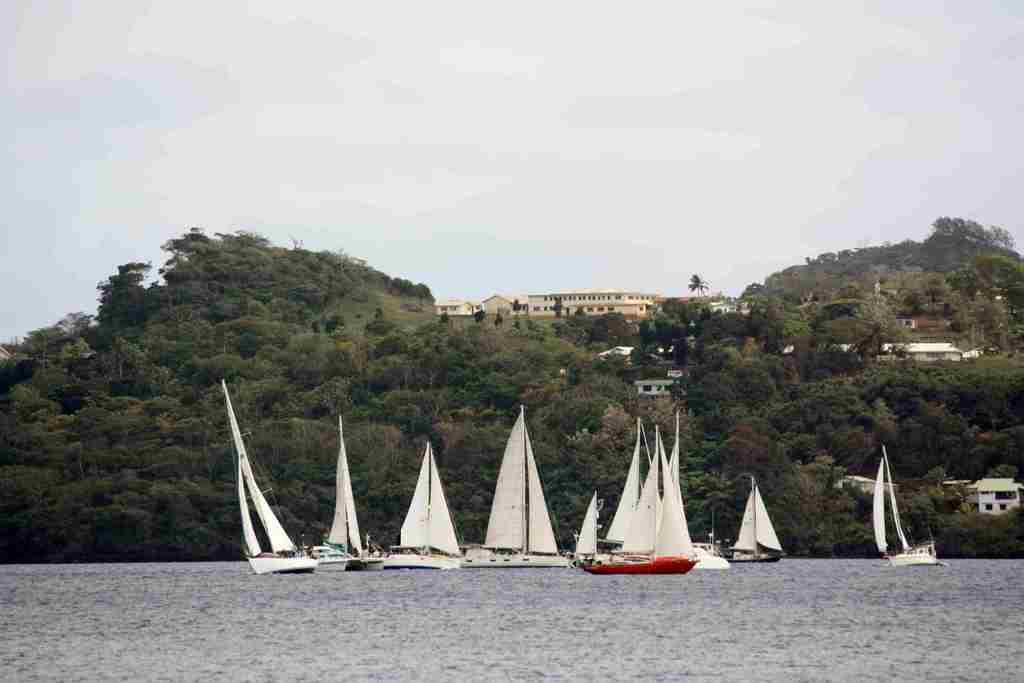What type of vehicles are in the image? There are boats with masts in the image. Where are the boats located? The boats are on the water surface. What type of natural environment is visible in the image? There are trees visible in the image. What type of man-made structures can be seen in the image? There are houses and buildings in the image. How many sisters are sitting in the office on the skate in the image? There are no sisters, offices, or skates present in the image. 